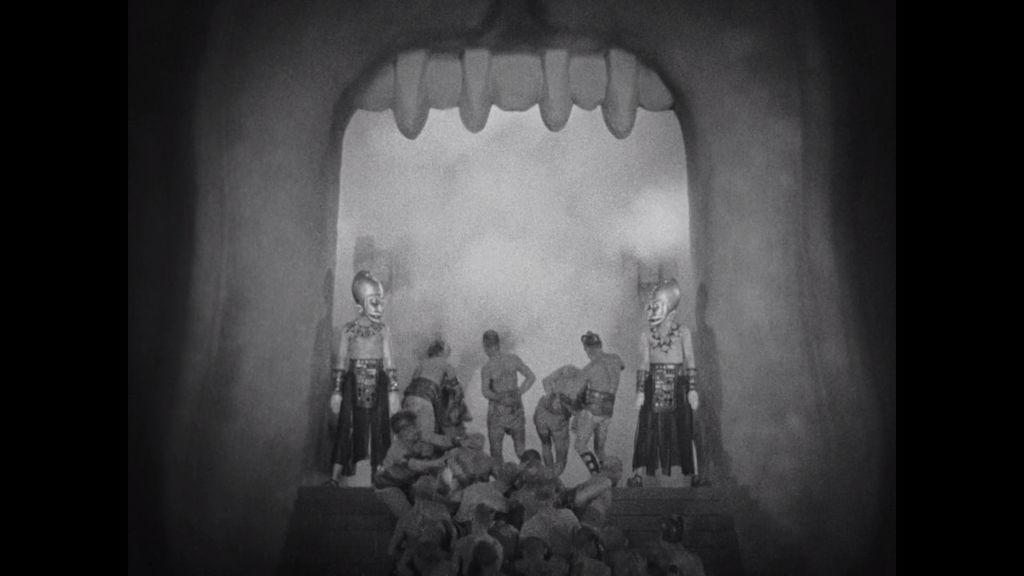What is the color scheme of the image? The image is black and white. What activity are the people in the image engaged in? The people in the image are performing in a play. Where is the kettle located in the image? There is no kettle present in the image. What type of shop can be seen in the background of the image? There is no shop visible in the image; it features people performing in a play. 